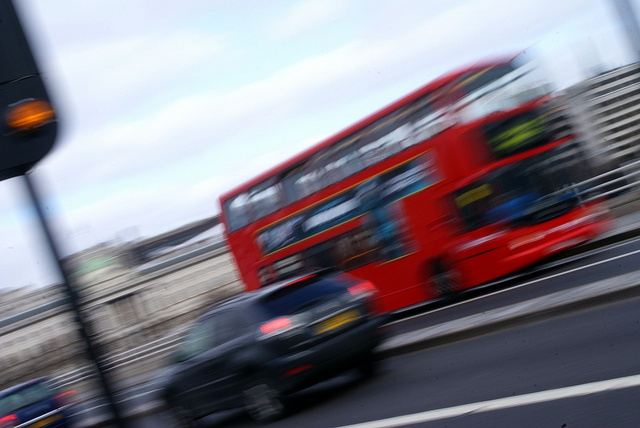Describe the objects in this image and their specific colors. I can see bus in black, maroon, and gray tones, car in black, gray, navy, and darkblue tones, traffic light in black, maroon, and brown tones, and car in black, navy, gray, and blue tones in this image. 